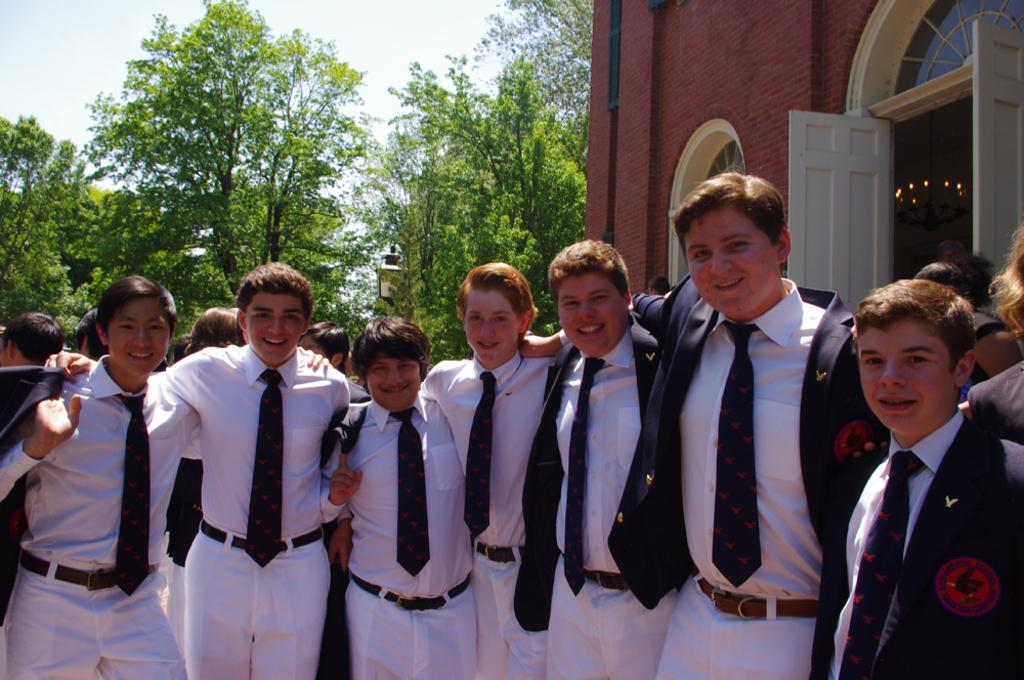What can be seen in the image? There are people standing in the image, along with a building. What is visible in the background of the image? There are trees in the background of the image. How would you describe the sky in the image? The sky is cloudy in the image. How many clovers can be seen growing on the building in the image? There are no clovers visible on the building in the image. 